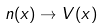<formula> <loc_0><loc_0><loc_500><loc_500>n ( x ) \rightarrow V ( x )</formula> 